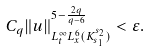Convert formula to latex. <formula><loc_0><loc_0><loc_500><loc_500>C _ { q } \| u \| _ { L _ { t } ^ { \infty } L _ { x } ^ { 6 } ( K _ { s _ { 1 } } ^ { s _ { 2 } } ) } ^ { 5 - \frac { 2 q } { q - 6 } } < \varepsilon . \\</formula> 